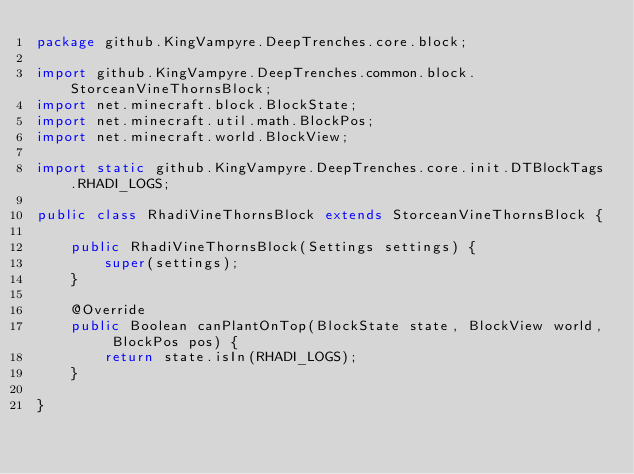Convert code to text. <code><loc_0><loc_0><loc_500><loc_500><_Java_>package github.KingVampyre.DeepTrenches.core.block;

import github.KingVampyre.DeepTrenches.common.block.StorceanVineThornsBlock;
import net.minecraft.block.BlockState;
import net.minecraft.util.math.BlockPos;
import net.minecraft.world.BlockView;

import static github.KingVampyre.DeepTrenches.core.init.DTBlockTags.RHADI_LOGS;

public class RhadiVineThornsBlock extends StorceanVineThornsBlock {

    public RhadiVineThornsBlock(Settings settings) {
        super(settings);
    }

    @Override
    public Boolean canPlantOnTop(BlockState state, BlockView world, BlockPos pos) {
        return state.isIn(RHADI_LOGS);
    }

}
</code> 